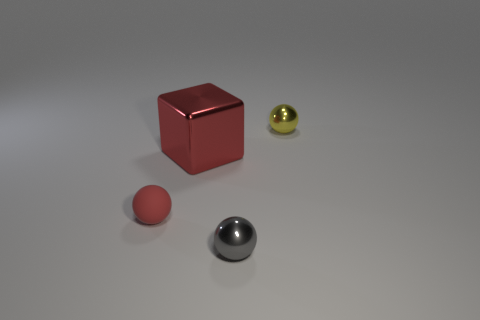Add 2 tiny matte things. How many objects exist? 6 Subtract all blocks. How many objects are left? 3 Subtract all big cyan balls. Subtract all large blocks. How many objects are left? 3 Add 2 small red rubber spheres. How many small red rubber spheres are left? 3 Add 4 big cylinders. How many big cylinders exist? 4 Subtract 1 gray spheres. How many objects are left? 3 